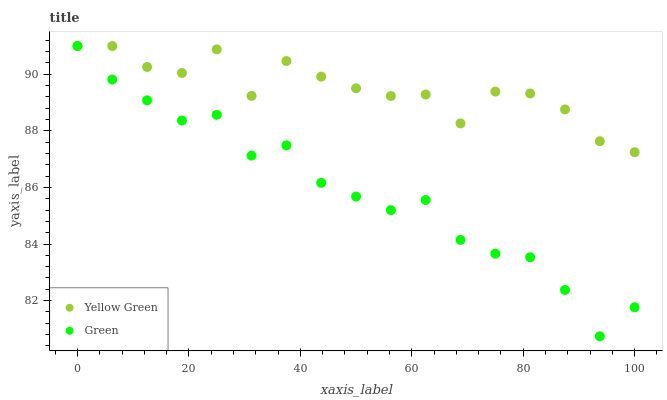Does Green have the minimum area under the curve?
Answer yes or no. Yes. Does Yellow Green have the maximum area under the curve?
Answer yes or no. Yes. Does Yellow Green have the minimum area under the curve?
Answer yes or no. No. Is Green the smoothest?
Answer yes or no. Yes. Is Yellow Green the roughest?
Answer yes or no. Yes. Is Yellow Green the smoothest?
Answer yes or no. No. Does Green have the lowest value?
Answer yes or no. Yes. Does Yellow Green have the lowest value?
Answer yes or no. No. Does Yellow Green have the highest value?
Answer yes or no. Yes. Does Green intersect Yellow Green?
Answer yes or no. Yes. Is Green less than Yellow Green?
Answer yes or no. No. Is Green greater than Yellow Green?
Answer yes or no. No. 